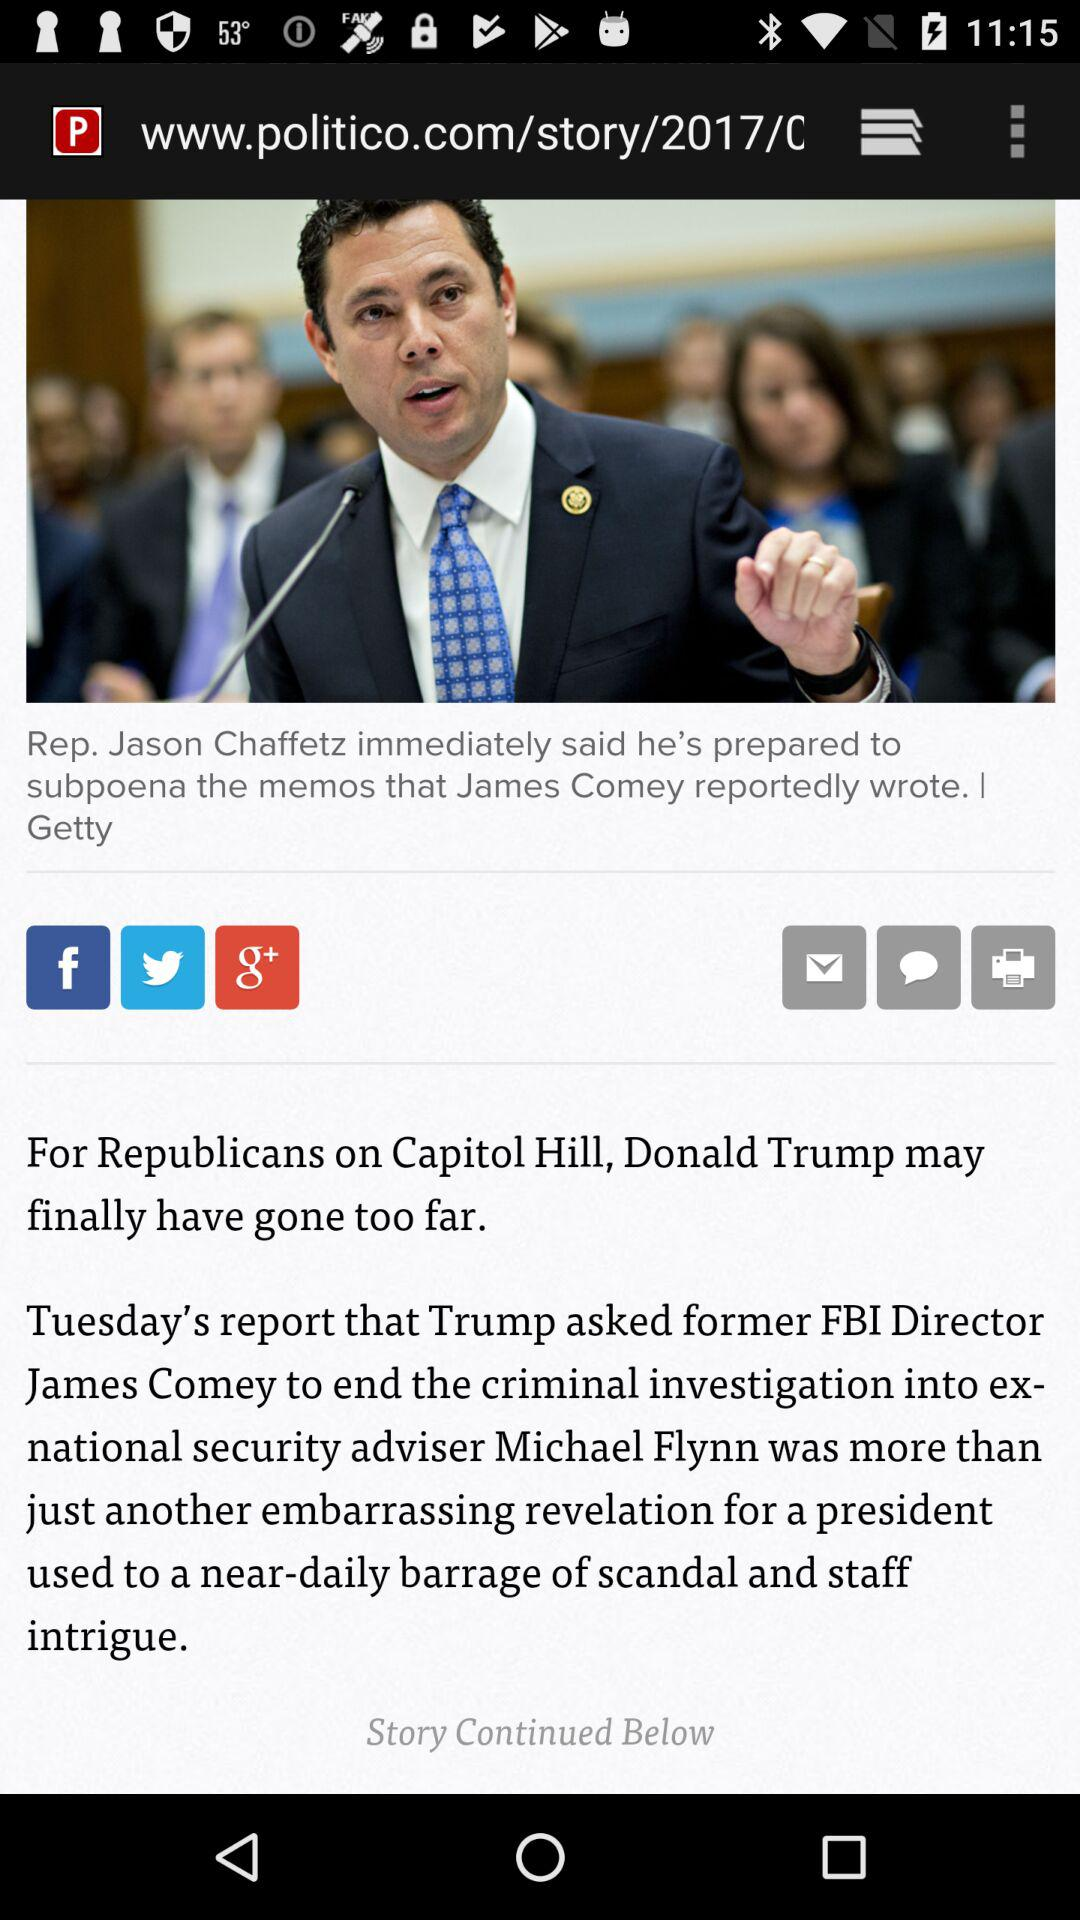Whom did Trump ask to end the criminal investigation into the ex-national security adviser? Trump asked former FBI Director James Comey to end the criminal investigation into the ex-national security adviser. 